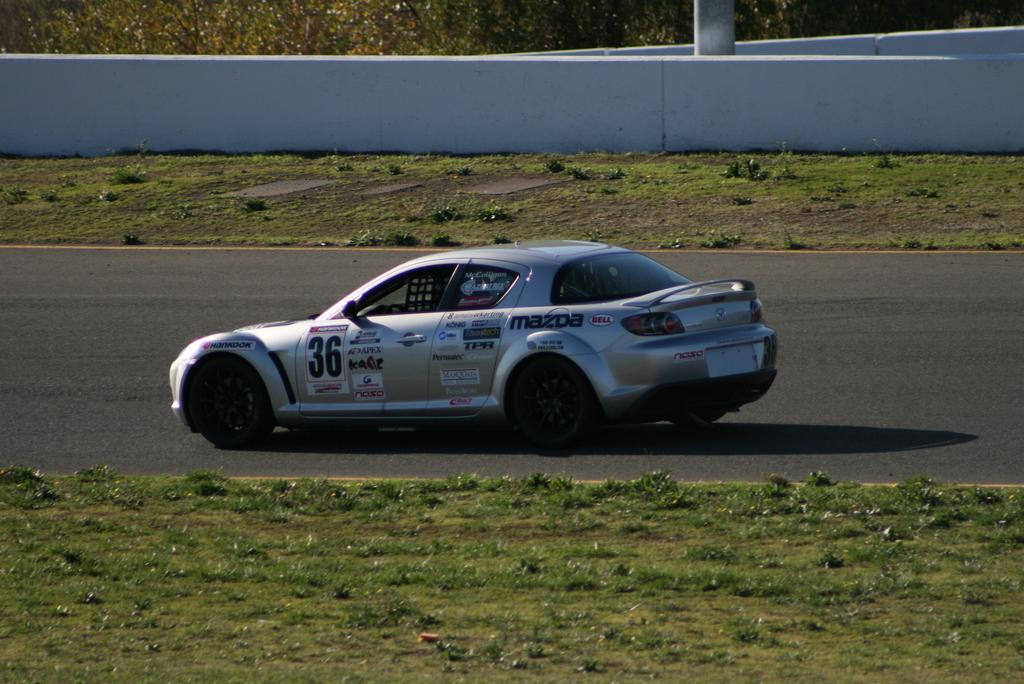What type of vehicle can be seen on the road in the image? There is a car on the road in the image. What type of vegetation is present in the image? There is grass in the image. What type of structure can be seen in the image? There is a fence wall in the image. What object is standing upright in the image? There is a pole in the image. What type of natural feature is present in the image? There are trees in the image. What type of card is being used to create the mist in the image? There is no card or mist present in the image. 